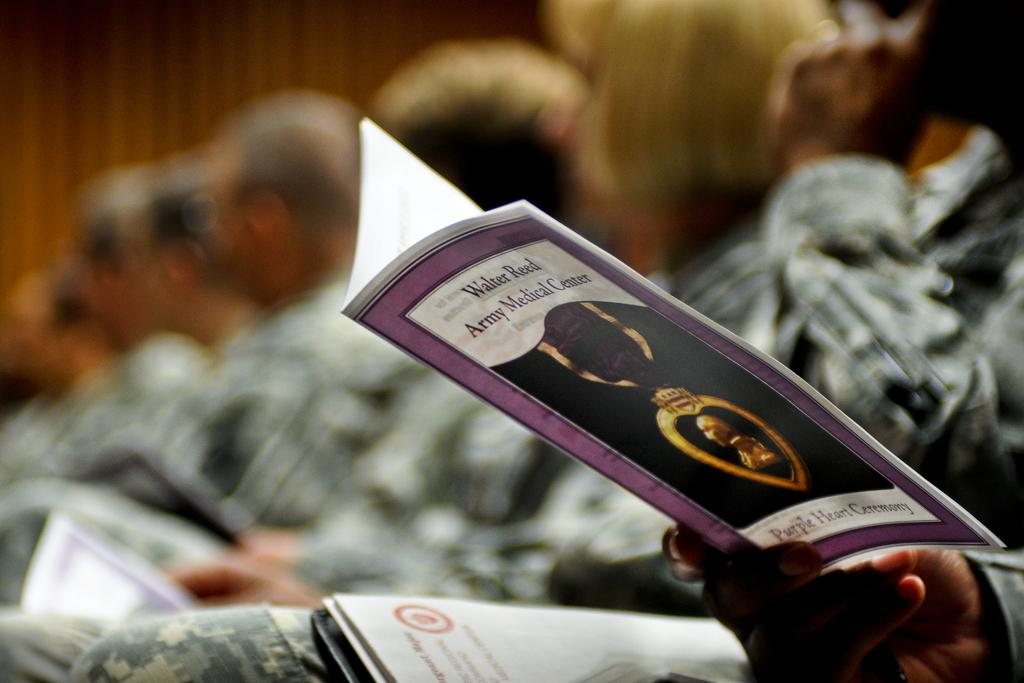<image>
Give a short and clear explanation of the subsequent image. A close up view of a program from the Walter Reed Army Medical Center. 